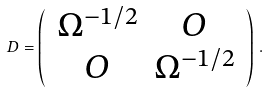Convert formula to latex. <formula><loc_0><loc_0><loc_500><loc_500>D = \left ( \, \begin{array} { c c } \Omega ^ { - 1 / 2 } & O \\ O & \Omega ^ { - 1 / 2 } \end{array} \, \right ) \, .</formula> 